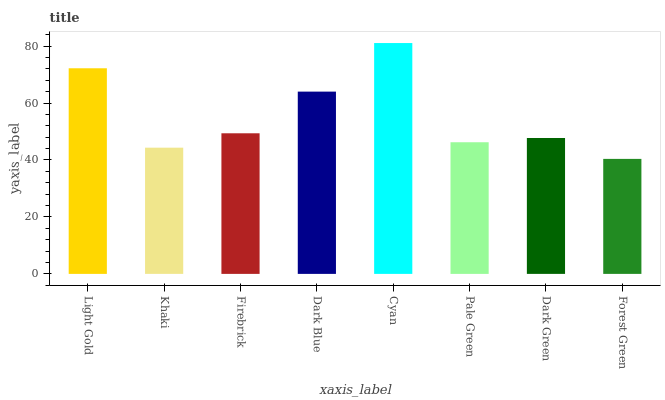Is Khaki the minimum?
Answer yes or no. No. Is Khaki the maximum?
Answer yes or no. No. Is Light Gold greater than Khaki?
Answer yes or no. Yes. Is Khaki less than Light Gold?
Answer yes or no. Yes. Is Khaki greater than Light Gold?
Answer yes or no. No. Is Light Gold less than Khaki?
Answer yes or no. No. Is Firebrick the high median?
Answer yes or no. Yes. Is Dark Green the low median?
Answer yes or no. Yes. Is Dark Blue the high median?
Answer yes or no. No. Is Dark Blue the low median?
Answer yes or no. No. 